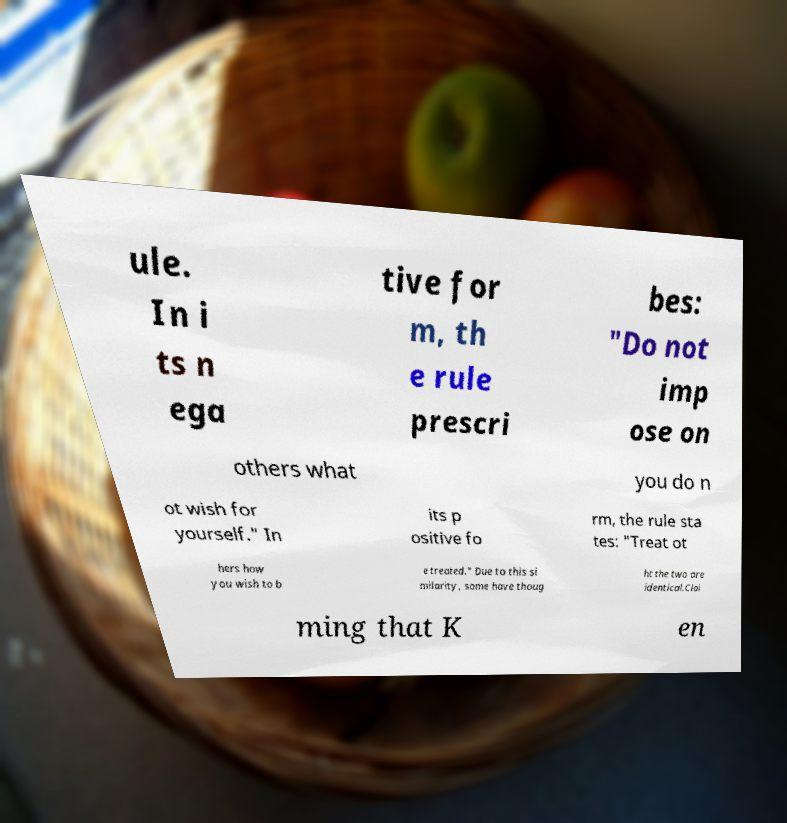There's text embedded in this image that I need extracted. Can you transcribe it verbatim? ule. In i ts n ega tive for m, th e rule prescri bes: "Do not imp ose on others what you do n ot wish for yourself." In its p ositive fo rm, the rule sta tes: "Treat ot hers how you wish to b e treated." Due to this si milarity, some have thoug ht the two are identical.Clai ming that K en 